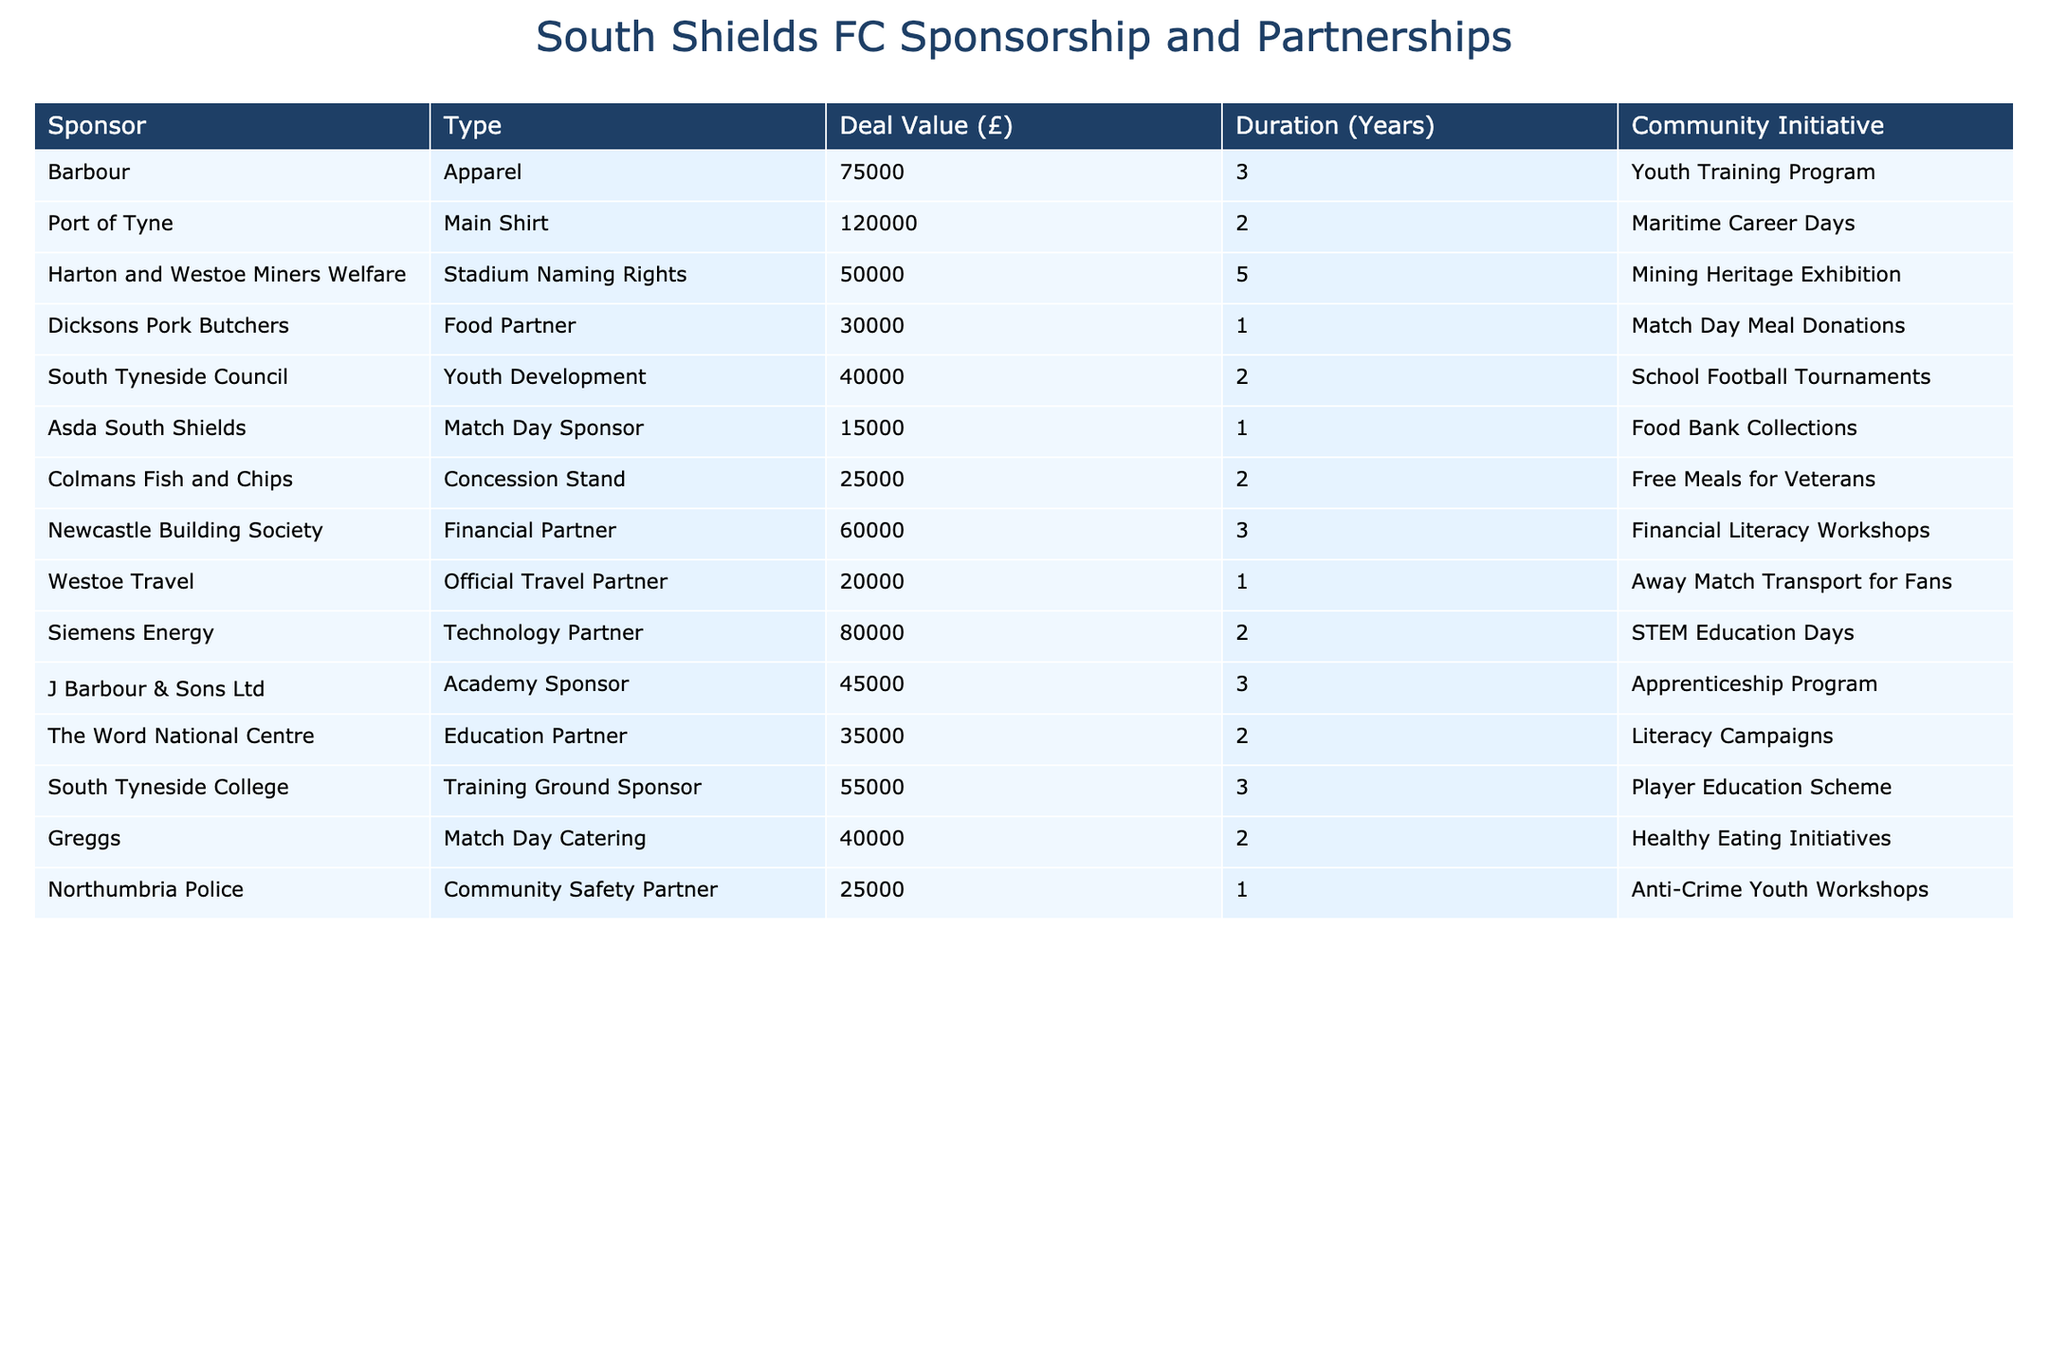What is the total deal value for all sponsorship deals? To find the total deal value, sum all the values in the "Deal Value (£)" column: 75000 + 120000 + 50000 + 30000 + 40000 + 15000 + 25000 + 60000 + 20000 + 80000 + 45000 + 35000 + 55000 + 40000 + 25000 = 563000.
Answer: 563000 How many years is the longest sponsorship deal duration? The longest duration is found by looking at the "Duration (Years)" column and identifying the maximum value, which is 5 years (for Harton and Westoe Miners Welfare).
Answer: 5 Is there a food partner sponsoring South Shields FC? Yes, there is a food partner, Dicksons Pork Butchers, indicated in the "Type" column.
Answer: Yes Which community initiative has the highest deal value? This requires checking the "Deal Value (£)" column along with the "Community Initiative" column. The highest value is £120000 associated with the Maritime Career Days initiative.
Answer: Maritime Career Days What is the average deal value of all partnerships with a duration of 2 years? To find this, select only the deals with a duration of 2 years and calculate the average: 120000 (Port of Tyne) + 40000 (South Tyneside Council) + 15000 (Asda South Shields) + 25000 (Colmans Fish and Chips) + 80000 (Siemens Energy) + 35000 (The Word National Centre) = 295000. There are 6 deals, so the average is 295000 / 6 = 49166.67.
Answer: 49166.67 Which sponsor is involved in the youth training program? The sponsor involved in the youth training program is Barbour, as listed in the "Community Initiative" column.
Answer: Barbour How many sponsors have a deal value of less than £30000? Check the "Deal Value (£)" column for values below 30000. There is only one sponsor, Asda South Shields, with a deal value of £15000.
Answer: 1 What is the combined duration for all sponsors with a focus on community safety? Only Northumbria Police is listed under community safety with a duration of 1 year, so the total duration is simply 1 year.
Answer: 1 Identify the technology partner and its deal value. The technology partner is Siemens Energy, and its deal value is £80000, as shown in the table.
Answer: Siemens Energy, £80000 Which community initiatives are associated with sponsors having deal values greater than £60000? Assess the sponsors with deal values over £60000: Barbour (£75000, Youth Training Program), Port of Tyne (£120000, Maritime Career Days), Newcastle Building Society (£60000, Financial Literacy Workshops), and Siemens Energy (£80000, STEM Education Days). The associated initiatives are Youth Training Program, Maritime Career Days, Financial Literacy Workshops, and STEM Education Days.
Answer: Youth Training Program, Maritime Career Days, Financial Literacy Workshops, STEM Education Days What percentage of the total deal value is contributed by South Tyneside Council? First, find the deal value from South Tyneside Council (£40000), then calculate the percentage: (40000 / 563000) * 100 = 7.1%.
Answer: 7.1% 